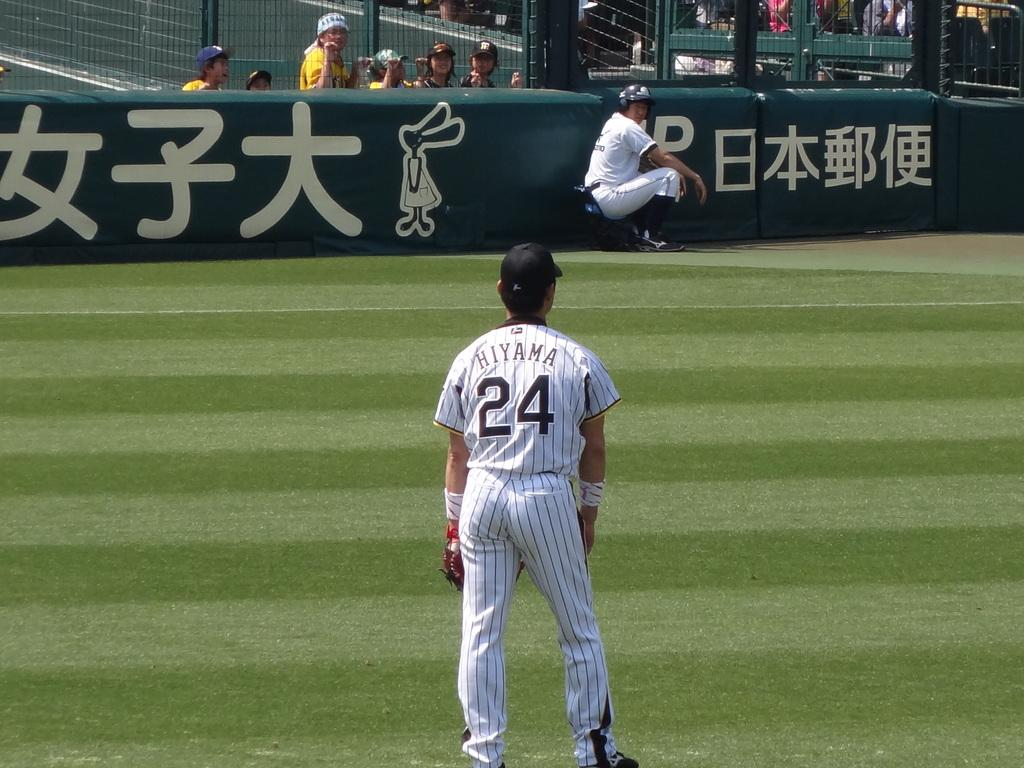Provide a one-sentence caption for the provided image. A man with the name Hiyama on his jersey stands on a baseball field. 